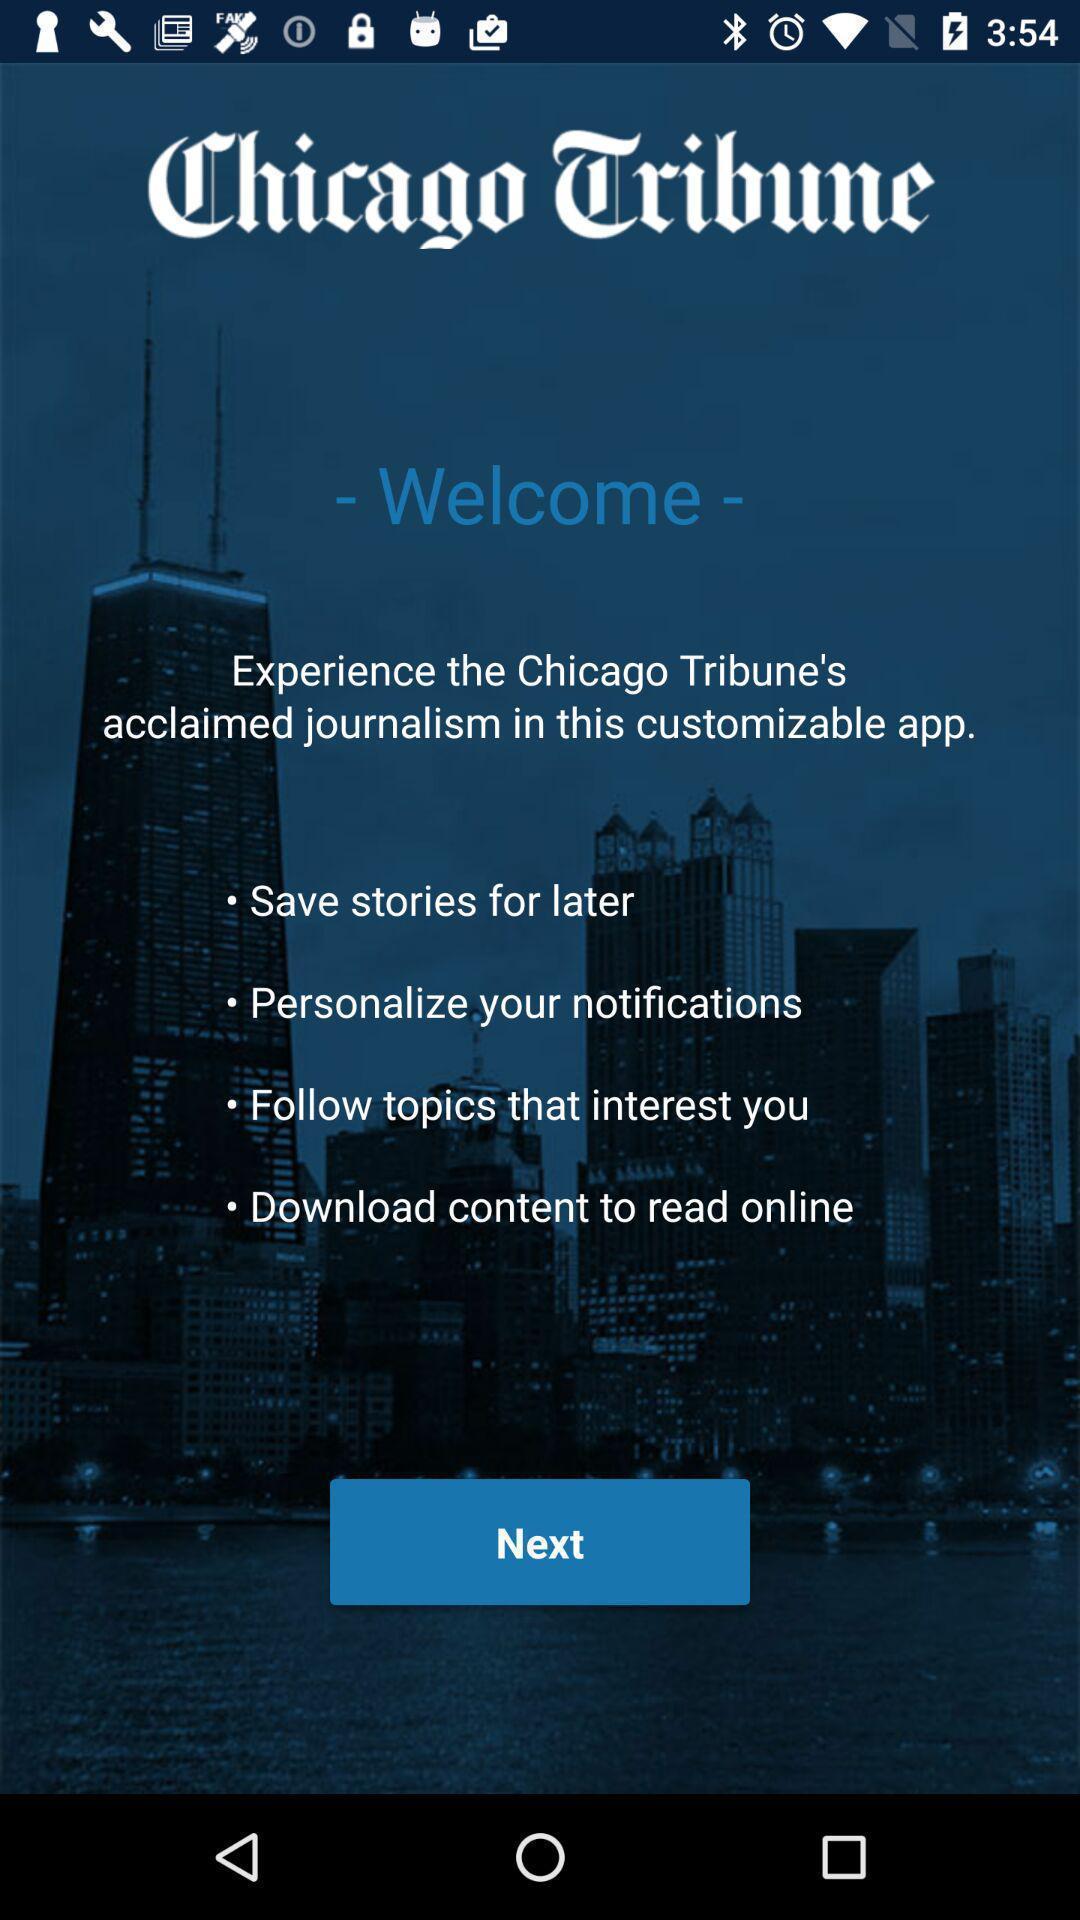What details can you identify in this image? Window displaying welcome page. 